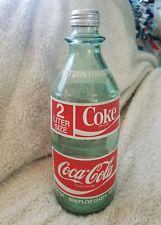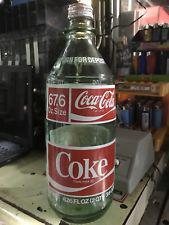The first image is the image on the left, the second image is the image on the right. For the images displayed, is the sentence "Pepsi brand is present." factually correct? Answer yes or no. No. 